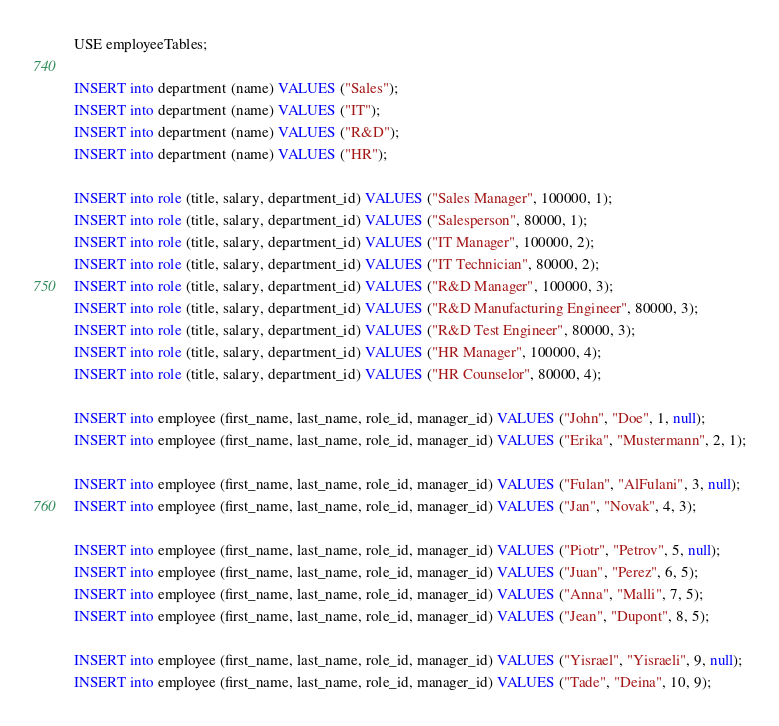Convert code to text. <code><loc_0><loc_0><loc_500><loc_500><_SQL_>USE employeeTables;

INSERT into department (name) VALUES ("Sales");
INSERT into department (name) VALUES ("IT");
INSERT into department (name) VALUES ("R&D");
INSERT into department (name) VALUES ("HR");

INSERT into role (title, salary, department_id) VALUES ("Sales Manager", 100000, 1);
INSERT into role (title, salary, department_id) VALUES ("Salesperson", 80000, 1);
INSERT into role (title, salary, department_id) VALUES ("IT Manager", 100000, 2);
INSERT into role (title, salary, department_id) VALUES ("IT Technician", 80000, 2);
INSERT into role (title, salary, department_id) VALUES ("R&D Manager", 100000, 3);
INSERT into role (title, salary, department_id) VALUES ("R&D Manufacturing Engineer", 80000, 3);
INSERT into role (title, salary, department_id) VALUES ("R&D Test Engineer", 80000, 3);
INSERT into role (title, salary, department_id) VALUES ("HR Manager", 100000, 4);
INSERT into role (title, salary, department_id) VALUES ("HR Counselor", 80000, 4);

INSERT into employee (first_name, last_name, role_id, manager_id) VALUES ("John", "Doe", 1, null);
INSERT into employee (first_name, last_name, role_id, manager_id) VALUES ("Erika", "Mustermann", 2, 1);

INSERT into employee (first_name, last_name, role_id, manager_id) VALUES ("Fulan", "AlFulani", 3, null);
INSERT into employee (first_name, last_name, role_id, manager_id) VALUES ("Jan", "Novak", 4, 3);

INSERT into employee (first_name, last_name, role_id, manager_id) VALUES ("Piotr", "Petrov", 5, null);
INSERT into employee (first_name, last_name, role_id, manager_id) VALUES ("Juan", "Perez", 6, 5);
INSERT into employee (first_name, last_name, role_id, manager_id) VALUES ("Anna", "Malli", 7, 5);
INSERT into employee (first_name, last_name, role_id, manager_id) VALUES ("Jean", "Dupont", 8, 5);

INSERT into employee (first_name, last_name, role_id, manager_id) VALUES ("Yisrael", "Yisraeli", 9, null);
INSERT into employee (first_name, last_name, role_id, manager_id) VALUES ("Tade", "Deina", 10, 9);</code> 